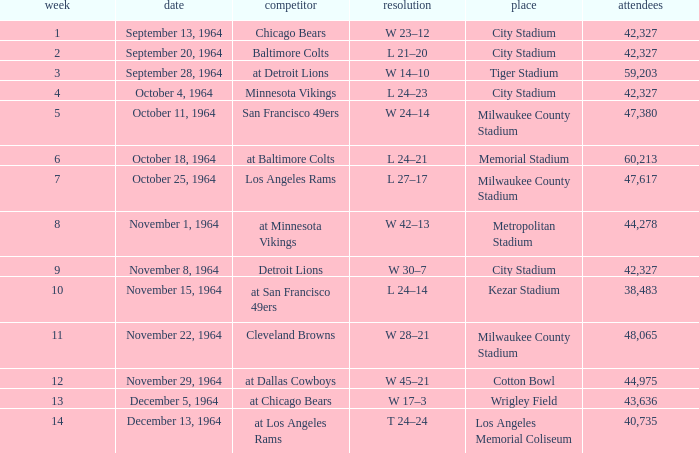What venue held that game with a result of l 24–14? Kezar Stadium. 